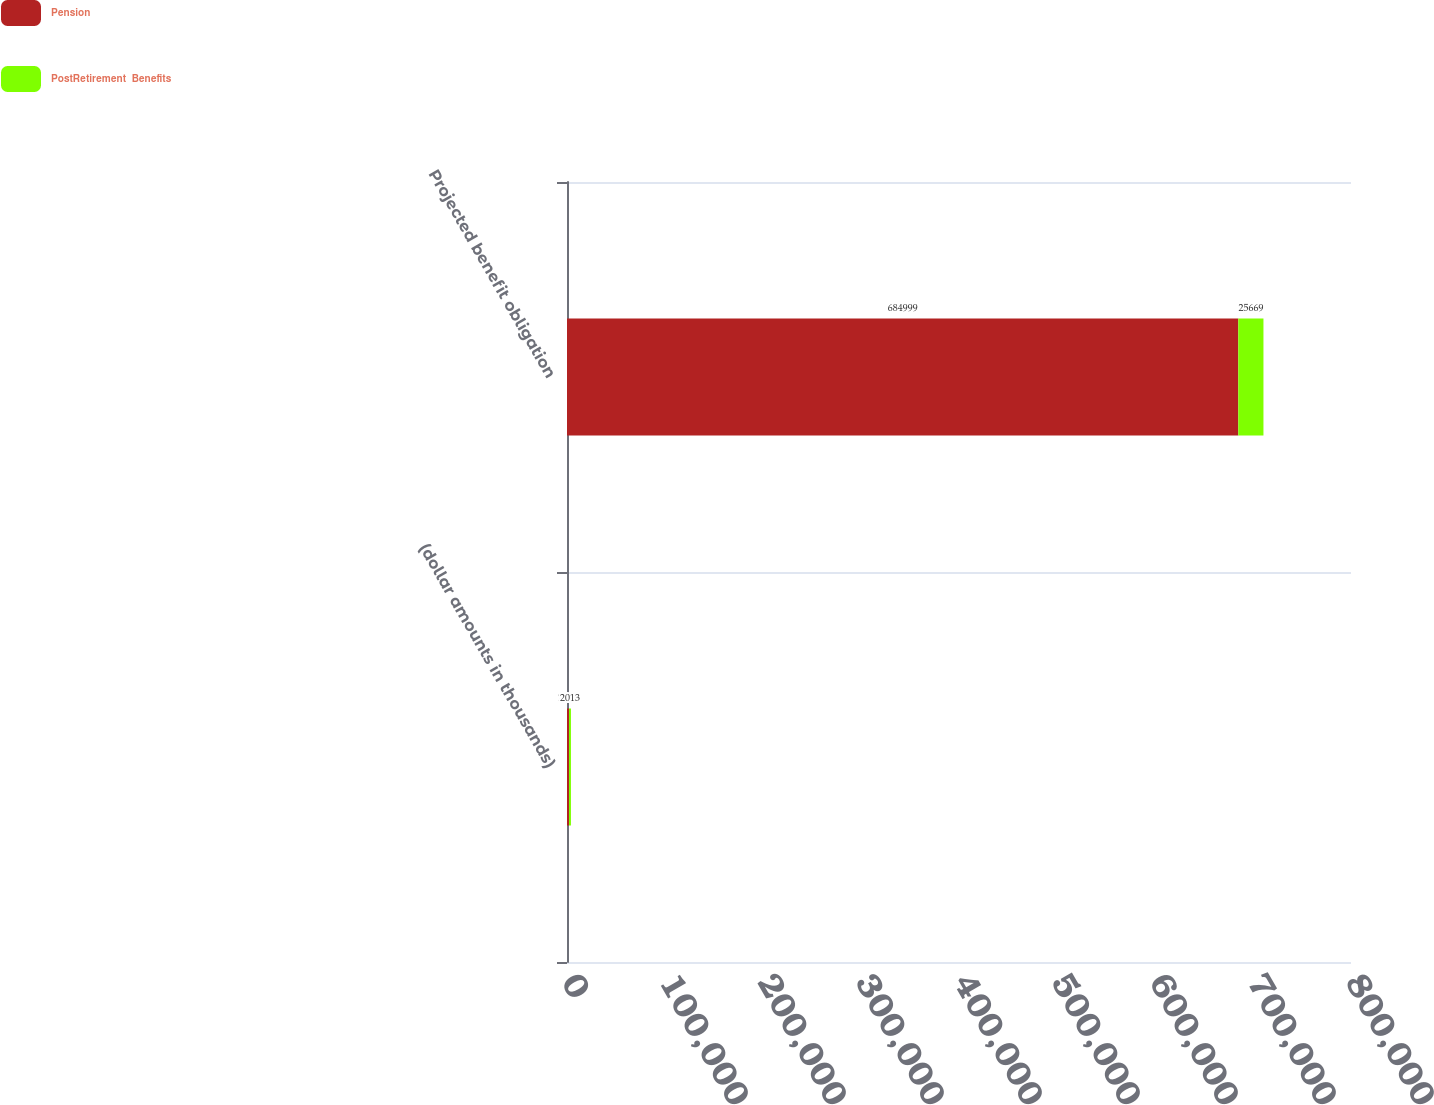Convert chart to OTSL. <chart><loc_0><loc_0><loc_500><loc_500><stacked_bar_chart><ecel><fcel>(dollar amounts in thousands)<fcel>Projected benefit obligation<nl><fcel>Pension<fcel>2013<fcel>684999<nl><fcel>PostRetirement  Benefits<fcel>2013<fcel>25669<nl></chart> 